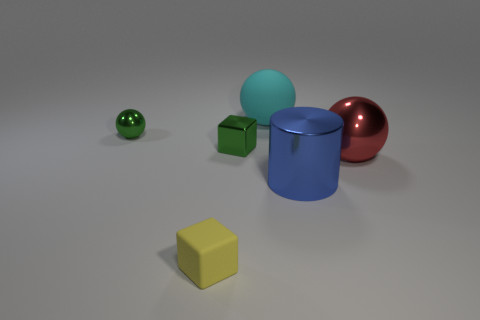There is a tiny object that is on the right side of the green ball and behind the tiny matte thing; what is its material?
Your answer should be very brief. Metal. How many green metal objects are the same shape as the blue metal thing?
Ensure brevity in your answer.  0. What color is the cube behind the rubber thing in front of the red object?
Keep it short and to the point. Green. Are there the same number of large rubber spheres that are in front of the large cyan rubber object and rubber things?
Make the answer very short. No. Is there a purple thing of the same size as the blue thing?
Your answer should be compact. No. Do the shiny cylinder and the block that is to the right of the small yellow matte thing have the same size?
Provide a short and direct response. No. Is the number of yellow things that are right of the red ball the same as the number of small metallic blocks that are to the left of the tiny green sphere?
Give a very brief answer. Yes. What is the shape of the tiny object that is the same color as the metal cube?
Provide a succinct answer. Sphere. What is the cube behind the blue object made of?
Your answer should be compact. Metal. Is the size of the blue cylinder the same as the yellow matte thing?
Your response must be concise. No. 